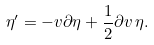<formula> <loc_0><loc_0><loc_500><loc_500>\eta ^ { \prime } = - v \partial \eta + \frac { 1 } { 2 } \partial v \, \eta .</formula> 